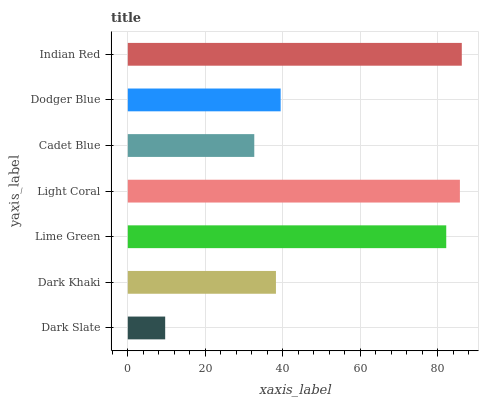Is Dark Slate the minimum?
Answer yes or no. Yes. Is Indian Red the maximum?
Answer yes or no. Yes. Is Dark Khaki the minimum?
Answer yes or no. No. Is Dark Khaki the maximum?
Answer yes or no. No. Is Dark Khaki greater than Dark Slate?
Answer yes or no. Yes. Is Dark Slate less than Dark Khaki?
Answer yes or no. Yes. Is Dark Slate greater than Dark Khaki?
Answer yes or no. No. Is Dark Khaki less than Dark Slate?
Answer yes or no. No. Is Dodger Blue the high median?
Answer yes or no. Yes. Is Dodger Blue the low median?
Answer yes or no. Yes. Is Indian Red the high median?
Answer yes or no. No. Is Lime Green the low median?
Answer yes or no. No. 